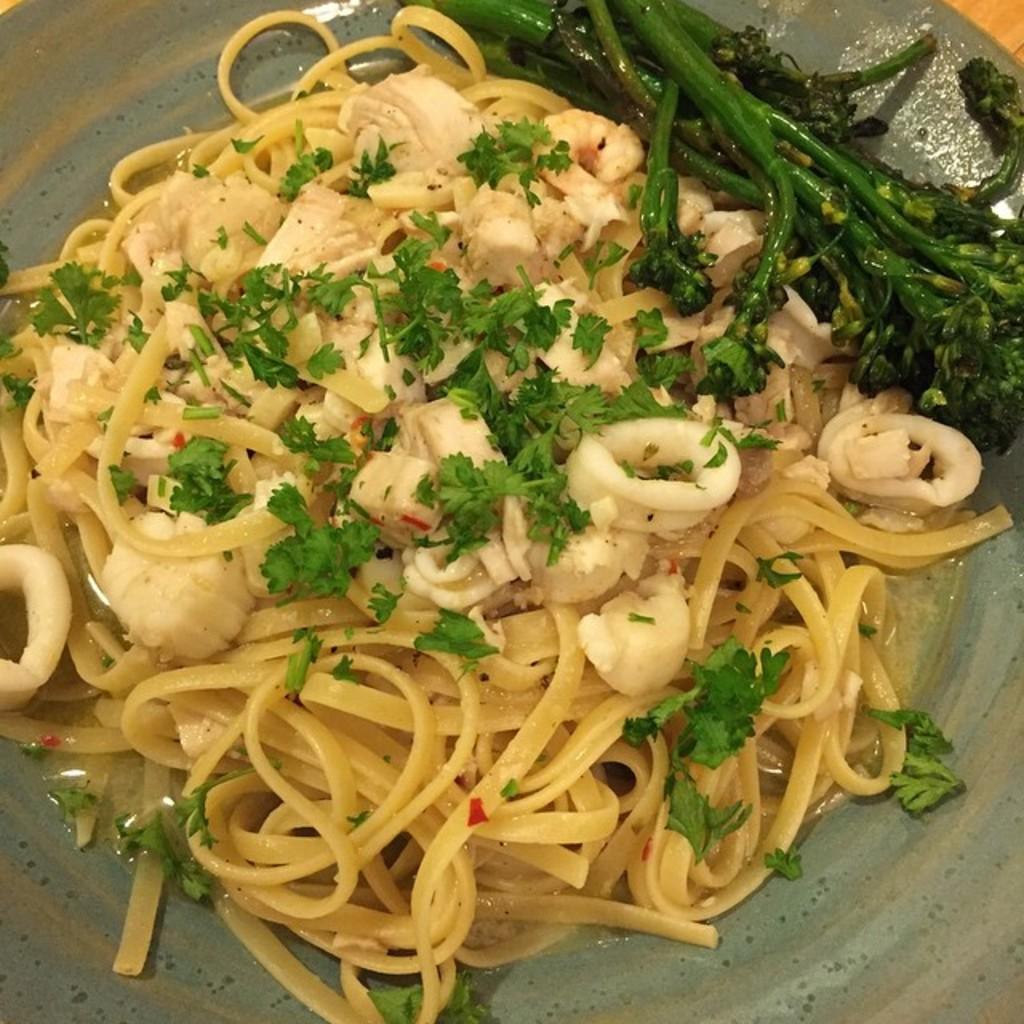What is placed on the surface in the image? There is food placed in a plate on the surface. Can you describe the plate and its contents? The plate is a flat dish that holds food. Where is the plate located in the image? The plate is kept on a surface, which could be a table, countertop, or other flat surface. How many legs does the food have in the image? The food does not have legs; it is placed on a plate and kept on a surface. 